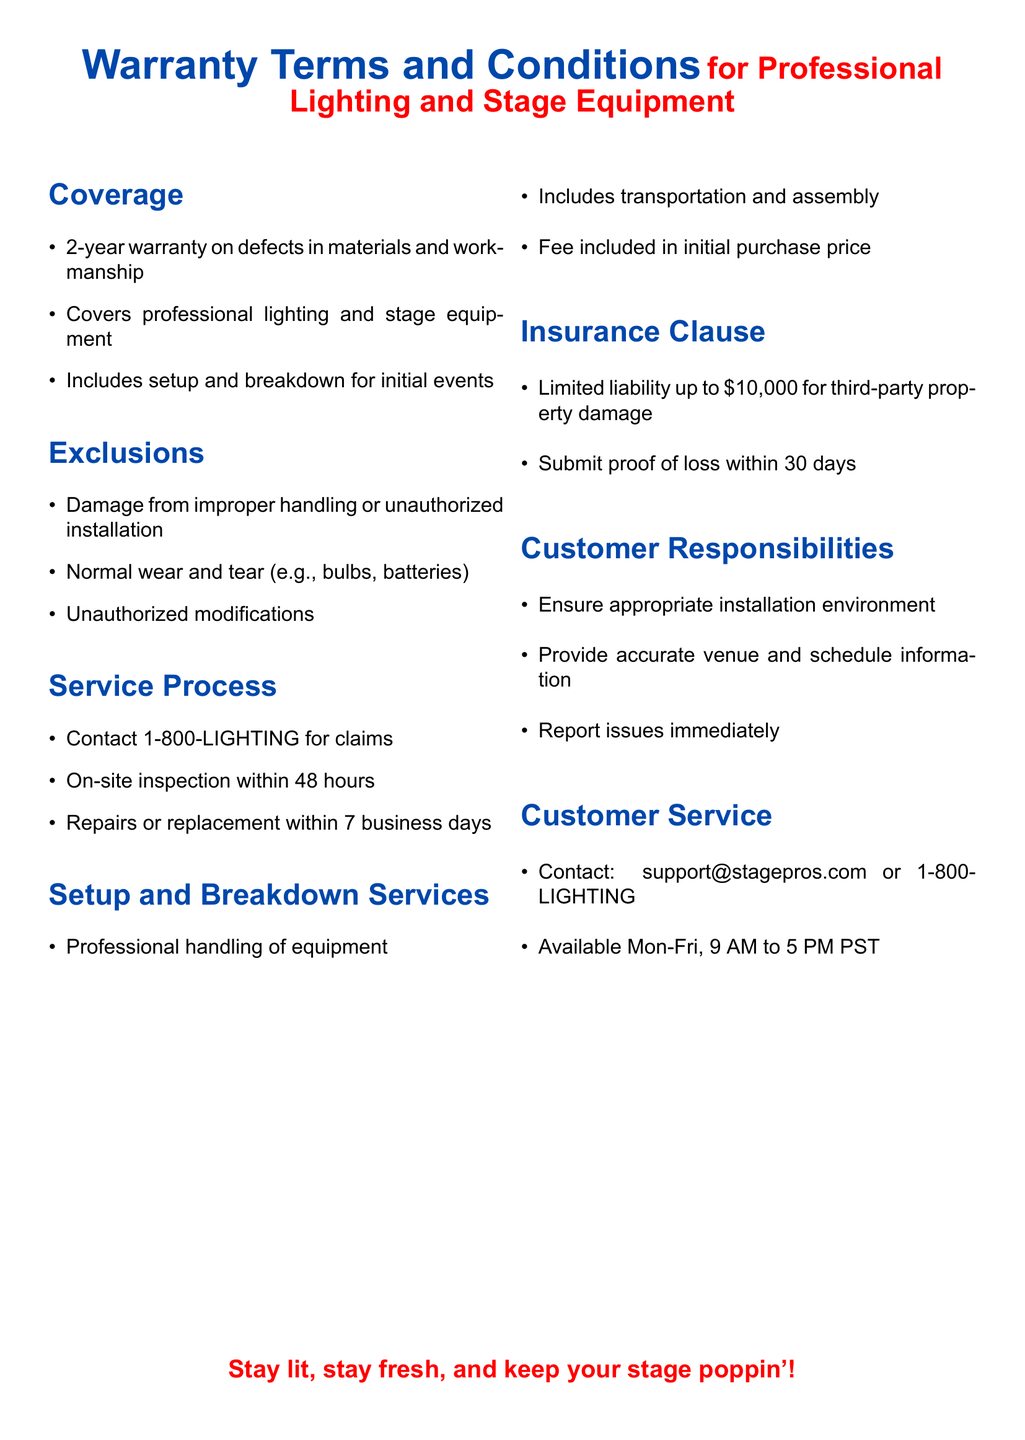What is the warranty period? The document states that the warranty period is for 2 years on defects in materials and workmanship.
Answer: 2 years What is covered under the warranty? The warranty covers professional lighting and stage equipment and includes setup and breakdown for initial events.
Answer: Professional lighting and stage equipment What is the contact number for claims? The document specifies that claims can be contacted through the number provided, which is 1-800-LIGHTING.
Answer: 1-800-LIGHTING What is the liability limit for third-party property damage? The warranty mentions a limited liability amount for third-party property damage, which is specified in the insurance clause.
Answer: $10,000 What must be provided within 30 days for the insurance claim? The document requires the submission of proof of loss within the 30-day time frame for claims under the insurance clause.
Answer: Proof of loss What actions are excluded from warranty coverage? The exclusions list damage from improper handling or unauthorized installation, which means those actions are not covered.
Answer: Improper handling What is the timeframe for repairs or replacements? The document states that repairs or replacements will be completed within a specific number of business days after an inspection.
Answer: 7 business days What is the customer service email provided in the document? The warranty document provides an email contact for customer service inquiries, specifically stated for reaching out for support.
Answer: support@stagepros.com What type of service is included in the purchase price? The warranty mentions that professional handling of equipment, specifically transportation and assembly, is included in the purchase price.
Answer: Setup and Breakdown Services 